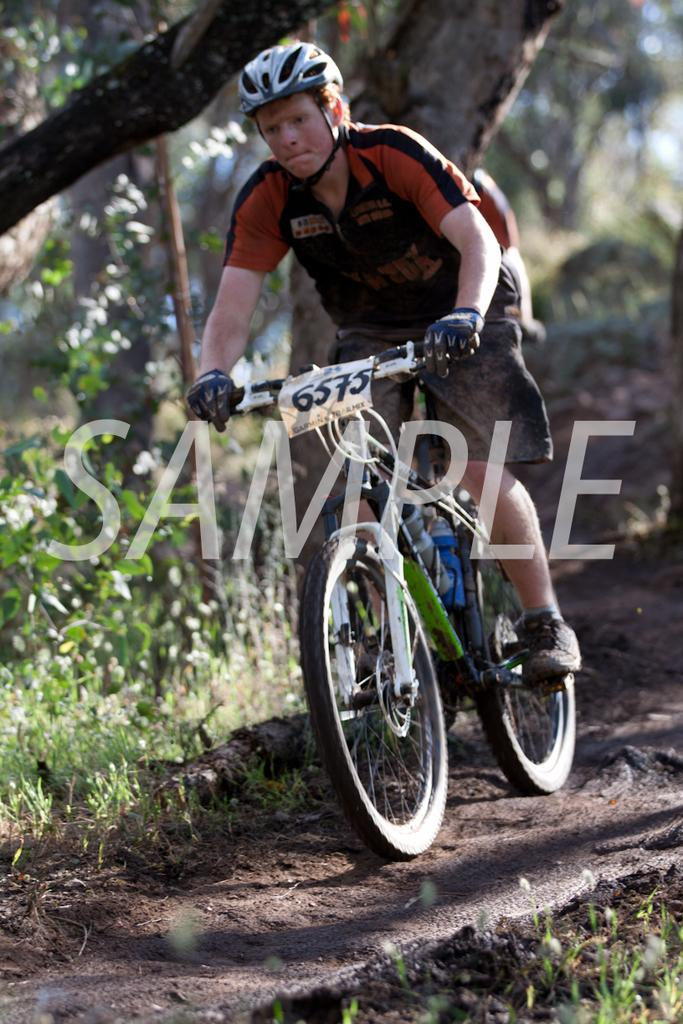What is the main subject of the image? The main subject of the image is a man. What is the man doing in the image? The man is riding a cycle in the image. What type of surface is the cycle on? The cycle is on a sand floor. Can you describe the background of the image? The background of the man is blurred. What type of chalk is the man using to draw on the lock in the image? A: There is no chalk or lock present in the image. What achievement has the man accomplished, as depicted in the image? The image does not show any specific achievements or accomplishments of the man. 